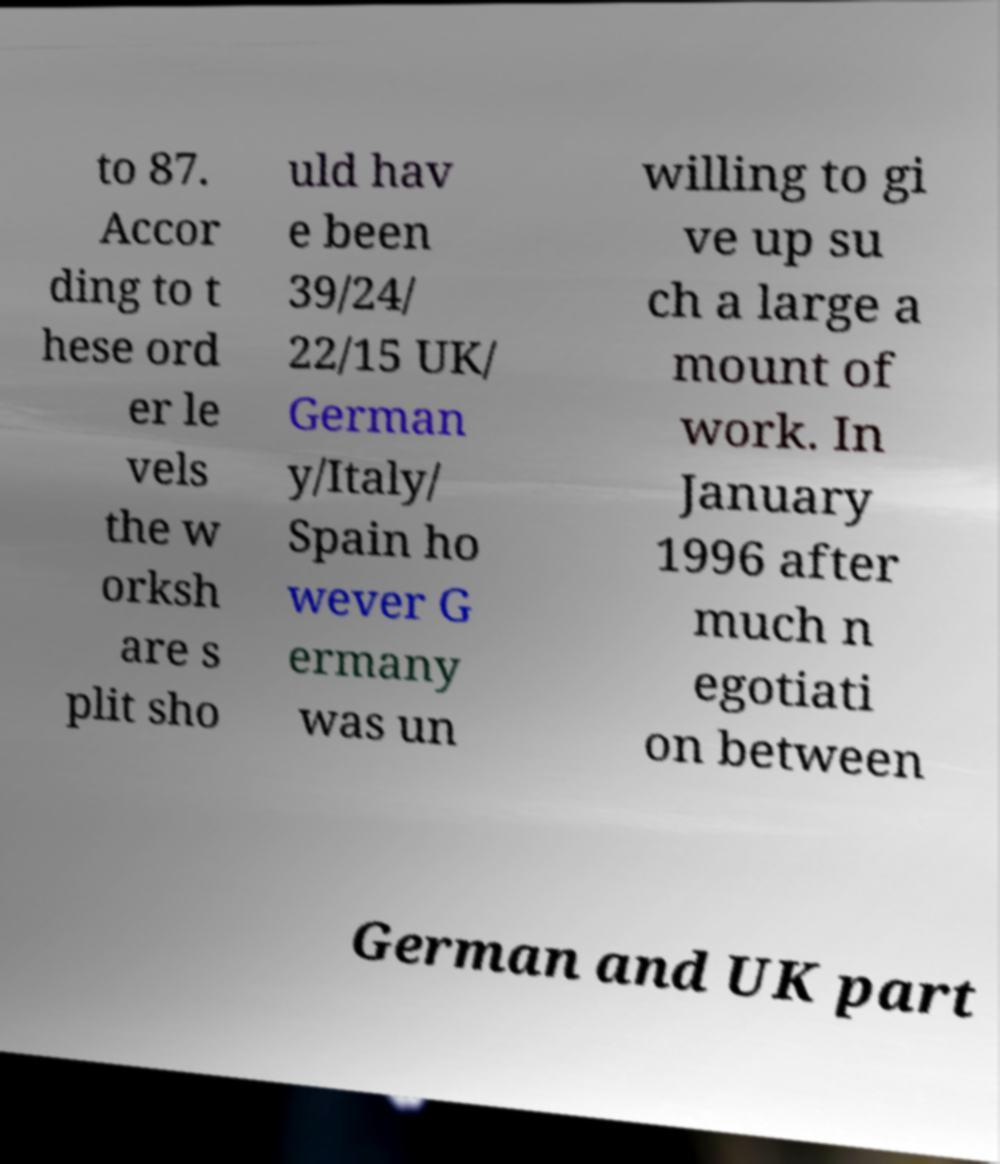There's text embedded in this image that I need extracted. Can you transcribe it verbatim? to 87. Accor ding to t hese ord er le vels the w orksh are s plit sho uld hav e been 39/24/ 22/15 UK/ German y/Italy/ Spain ho wever G ermany was un willing to gi ve up su ch a large a mount of work. In January 1996 after much n egotiati on between German and UK part 